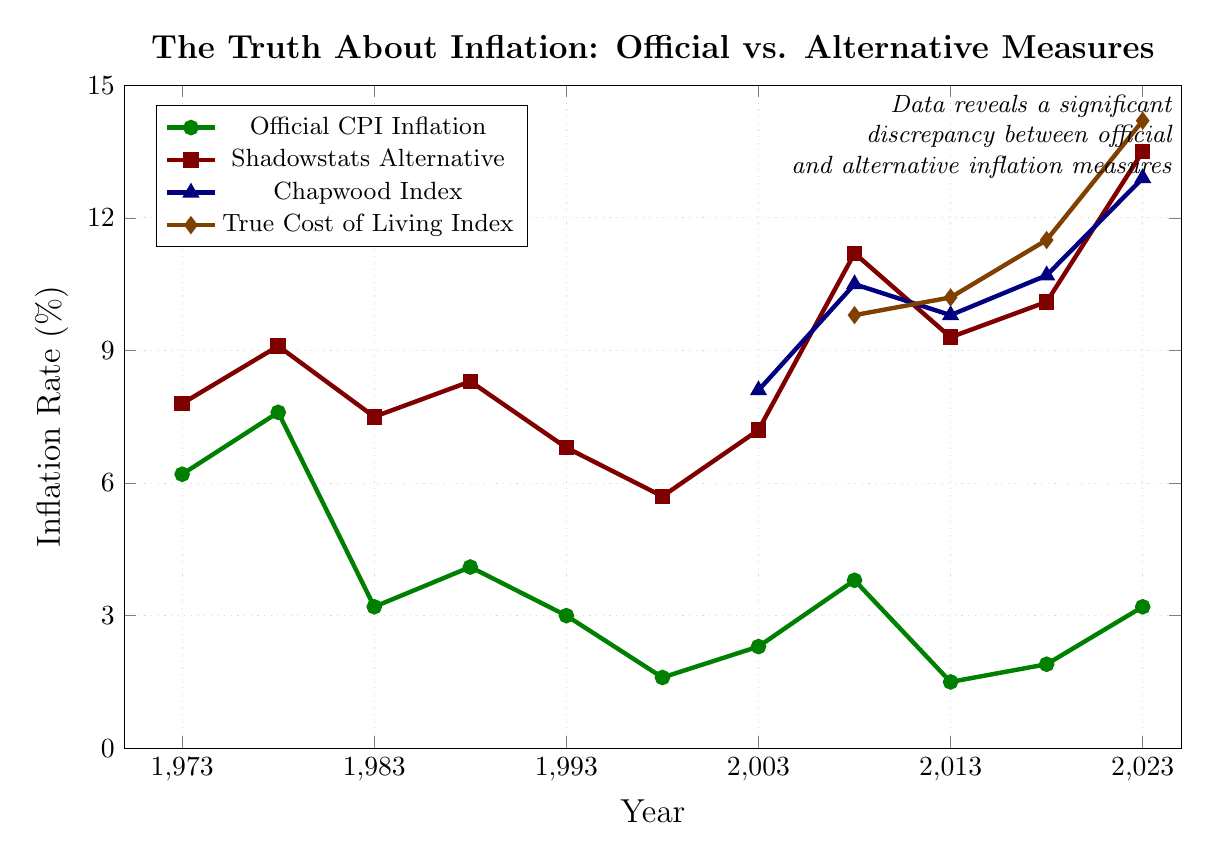What is the value of Shadowstats Alternative Inflation in 2018? The figure indicates Shadowstats Alternative Inflation of 10.1% in 2018.
Answer: 10.1% How did the Official CPI Inflation change from 1978 to 1983? The Official CPI Inflation decreased from 7.6% in 1978 to 3.2% in 1983, a reduction of 4.4%.
Answer: Decreased by 4.4% Which inflation measure shows the highest value in 2023? In the figure, the True Cost of Living Index has the highest value in 2023 at 14.2%.
Answer: True Cost of Living Index, 14.2% Compare the Official CPI Inflation and Shadowstats Alternative Inflation in 2008. Which one is higher? The Official CPI Inflation is 3.8% in 2008, while Shadowstats Alternative Inflation is 11.2%. Shadowstats Alternative Inflation is higher.
Answer: Shadowstats Alternative Inflation, 11.2% What is the difference between the Chapwood Index and the True Cost of Living Index in 2013? The Chapwood Index is 9.8% in 2013, while the True Cost of Living Index is 10.2%. The difference is 0.4%.
Answer: 0.4% Between 1993 and 1998, does the Shadowstats Alternative Inflation increase or decrease, and by how much? The figure shows that Shadowstats Alternative Inflation decreases from 6.8% in 1993 to 5.7% in 1998, a decrease of 1.1%.
Answer: Decreased by 1.1% Identify the years in which the Official CPI Inflation was less than 2%. The Official CPI Inflation values less than 2% are in the years 1998 (1.6%) and 2013 (1.5%).
Answer: 1998, 2013 What is the average value of the Official CPI Inflation rates in the years provided? The Official CPI Inflation rates are: 6.2, 7.6, 3.2, 4.1, 3.0, 1.6, 2.3, 3.8, 1.5, 1.9, 3.2. Adding these together gives 38.4, and dividing by 11 yields an average of approximately 3.49%.
Answer: 3.49% In which year did the Shadowstats Alternative Inflation first surpass double digits? In 2008, the Shadowstats Alternative Inflation surpasses double digits with a value of 11.2%.
Answer: 2008 Compare the trend of the Official CPI Inflation to that of the True Cost of Living Index between 2013 and 2023. From 2013 to 2023, the Official CPI Inflation increases slightly from 1.5% to 3.2%, while the True Cost of Living Index significantly rises from 10.2% to 14.2%, indicating a steeper increase for the True Cost of Living Index.
Answer: True Cost of Living Index increased more steeply 